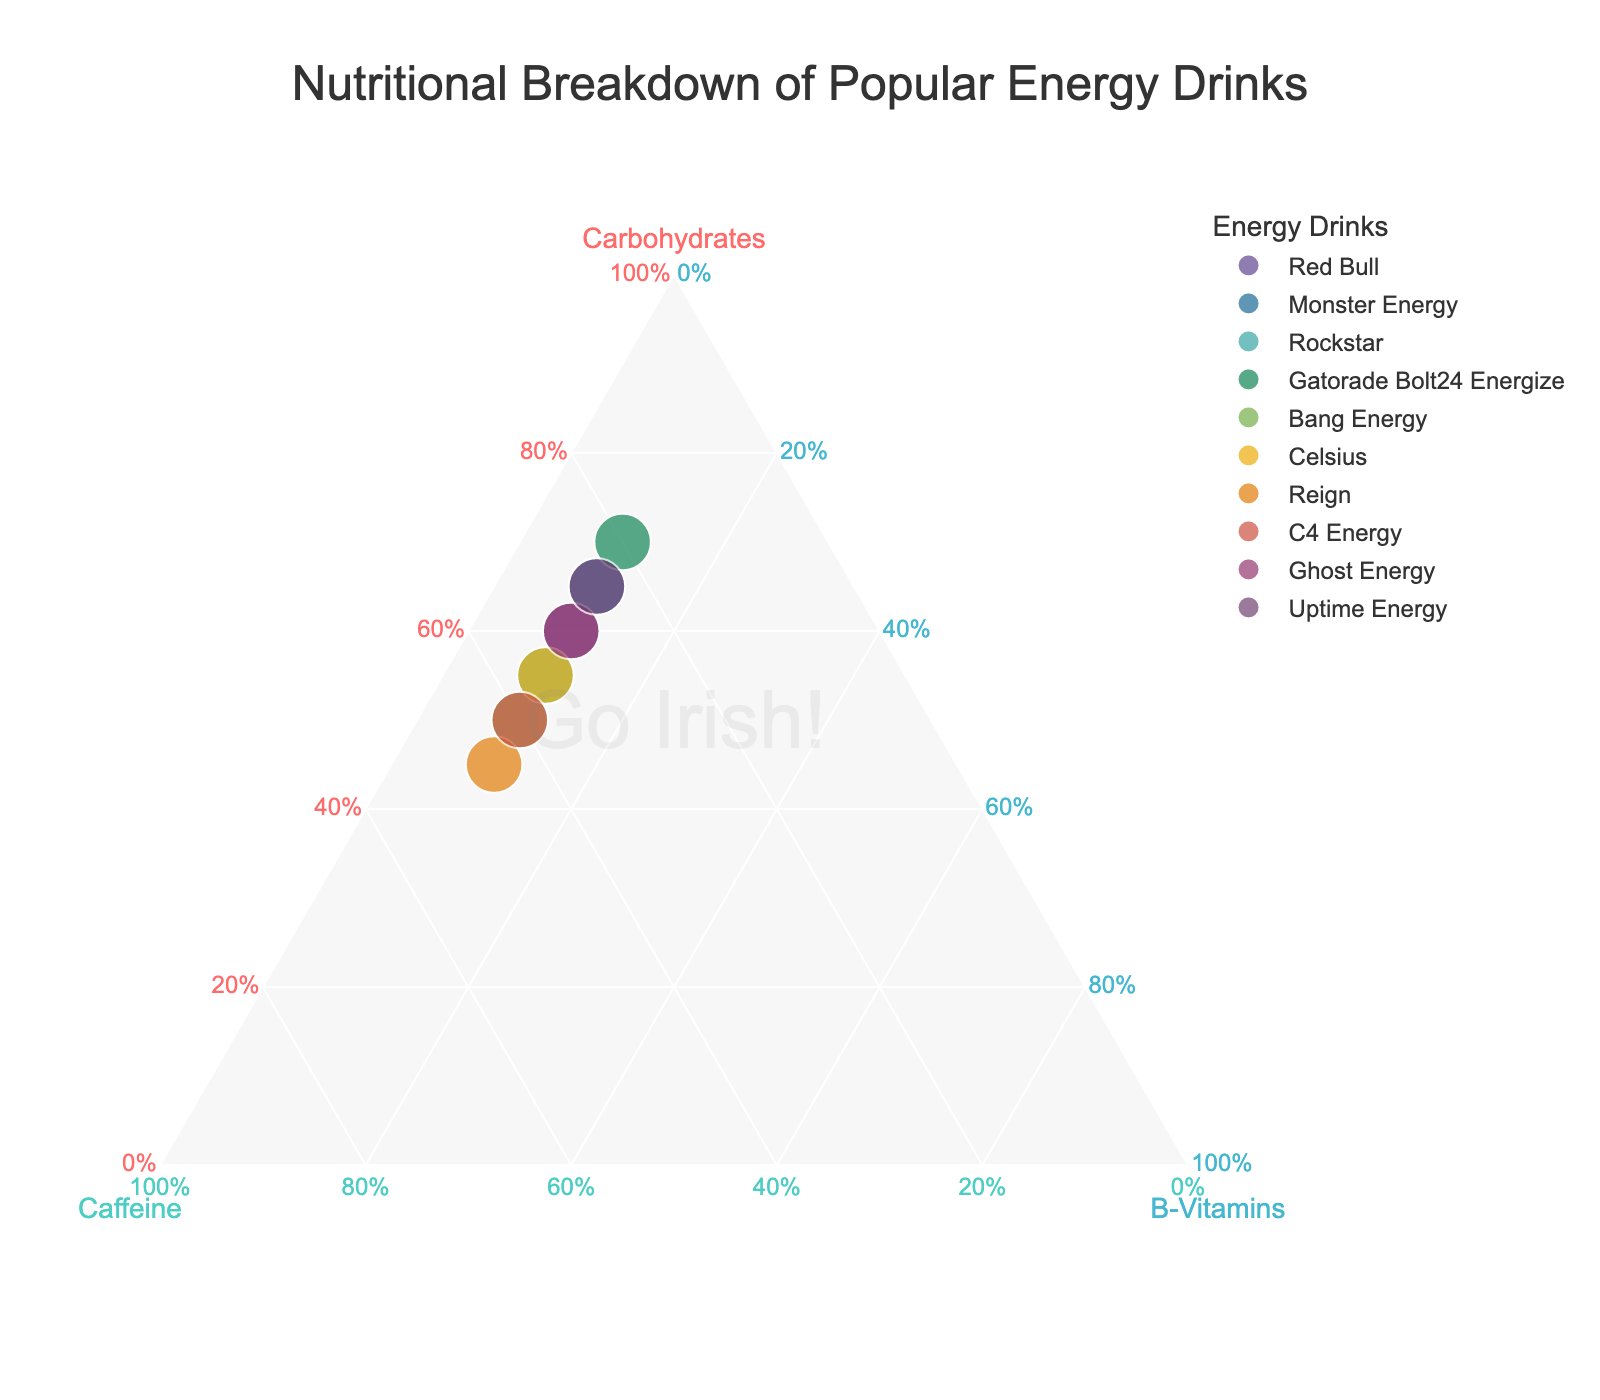How many energy drinks are represented in the figure? Count the number of unique data points listed.
Answer: 10 Which energy drink has the highest proportion of carbohydrates? Look for the data point located closest to the Carbohydrates axis (bottom-left).
Answer: Gatorade Bolt24 Energize What is the common proportion of B-Vitamins across all energy drinks? Notice that all data points have the same coordinate on the B-Vitamins axis.
Answer: 10% Which two energy drinks have identical proportions of nutrients? Determine if any pairs overlap or share the same normalized coordinates.
Answer: Celsius and Rockstar How does Bang Energy's caffeine proportion compare to Reign? Identify and compare the positions of Bang Energy and Reign along the Caffeine axis.
Answer: Bang Energy has less caffeine than Reign If you want an energy drink with the highest caffeine content, which drink would you choose? Locate the data point closest to the Caffeine axis (bottom-right).
Answer: Reign How do Monster Energy and Uptime Energy compare in terms of carbohydrate content? Compare their positions along the Carbohydrates axis.
Answer: Uptime Energy has higher carbohydrates On average, what proportion of carbohydrates do these energy drinks contain? Calculate the mean by summing up the carbohydrate proportions and dividing by the number of drinks. (60+65+55+70+50+55+45+50+60+65)/10
Answer: 57.5% Which energy drink has the highest proportional distribution across all three nutrients? Look for the data point closest to the center of the triangle.
Answer: No drink is at the center; they all have 10% B-Vitamins, a more equal spread would be judged among the remaining nutrients Compare the carbohydrate proportions between the drink with the least (Reign) and the most (Gatorade Bolt24 Energize) carbohydrate. Identify their positions on the Carbohydrates axis and compare.
Answer: Reign's proportion is significantly lower than Gatorade Bolt24 Energize 